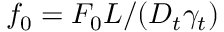<formula> <loc_0><loc_0><loc_500><loc_500>f _ { 0 } = F _ { 0 } L / ( D _ { t } \gamma _ { t } )</formula> 